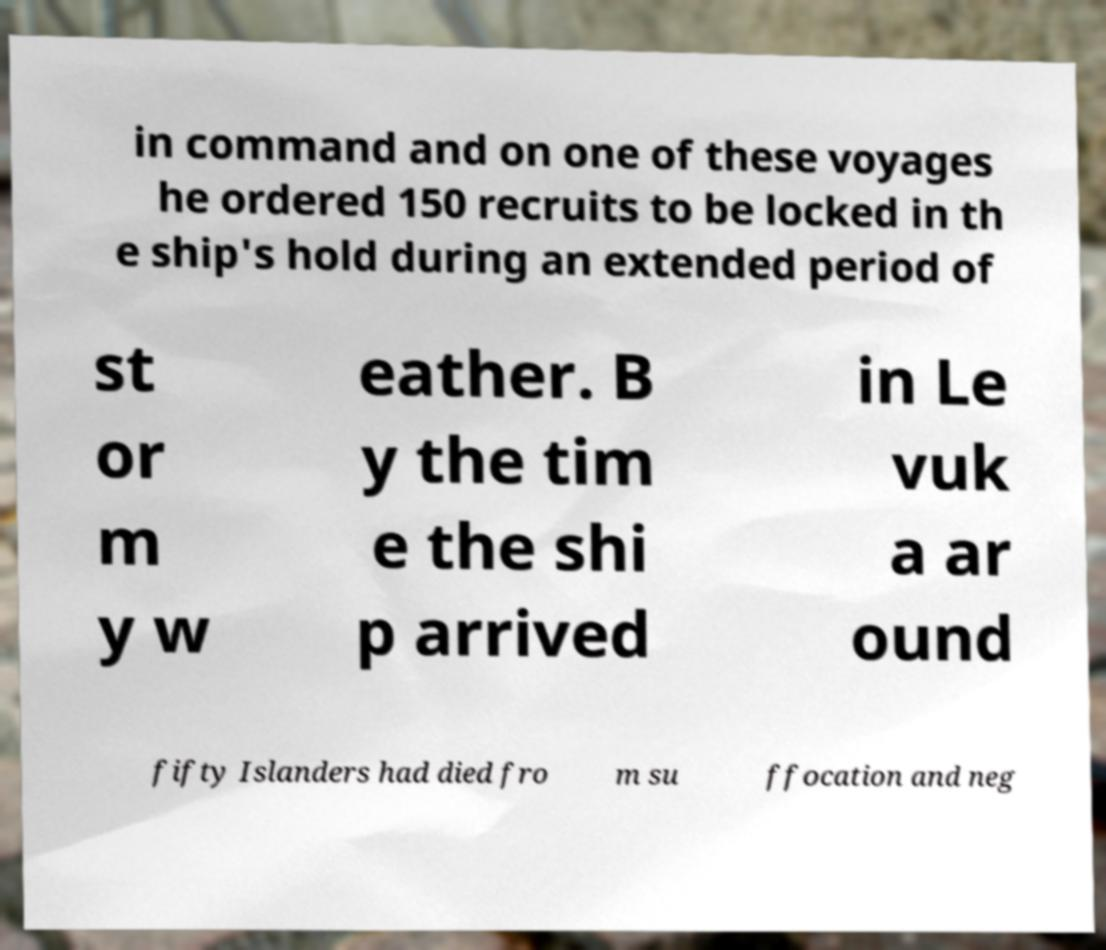Can you read and provide the text displayed in the image?This photo seems to have some interesting text. Can you extract and type it out for me? in command and on one of these voyages he ordered 150 recruits to be locked in th e ship's hold during an extended period of st or m y w eather. B y the tim e the shi p arrived in Le vuk a ar ound fifty Islanders had died fro m su ffocation and neg 